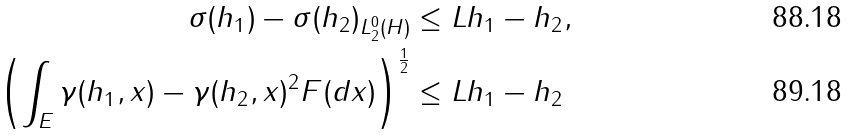Convert formula to latex. <formula><loc_0><loc_0><loc_500><loc_500>\| \sigma ( h _ { 1 } ) - \sigma ( h _ { 2 } ) \| _ { L _ { 2 } ^ { 0 } ( H ) } & \leq L \| h _ { 1 } - h _ { 2 } \| , \\ \left ( \int _ { E } \| \gamma ( h _ { 1 } , x ) - \gamma ( h _ { 2 } , x ) \| ^ { 2 } F ( d x ) \right ) ^ { \frac { 1 } { 2 } } & \leq L \| h _ { 1 } - h _ { 2 } \|</formula> 